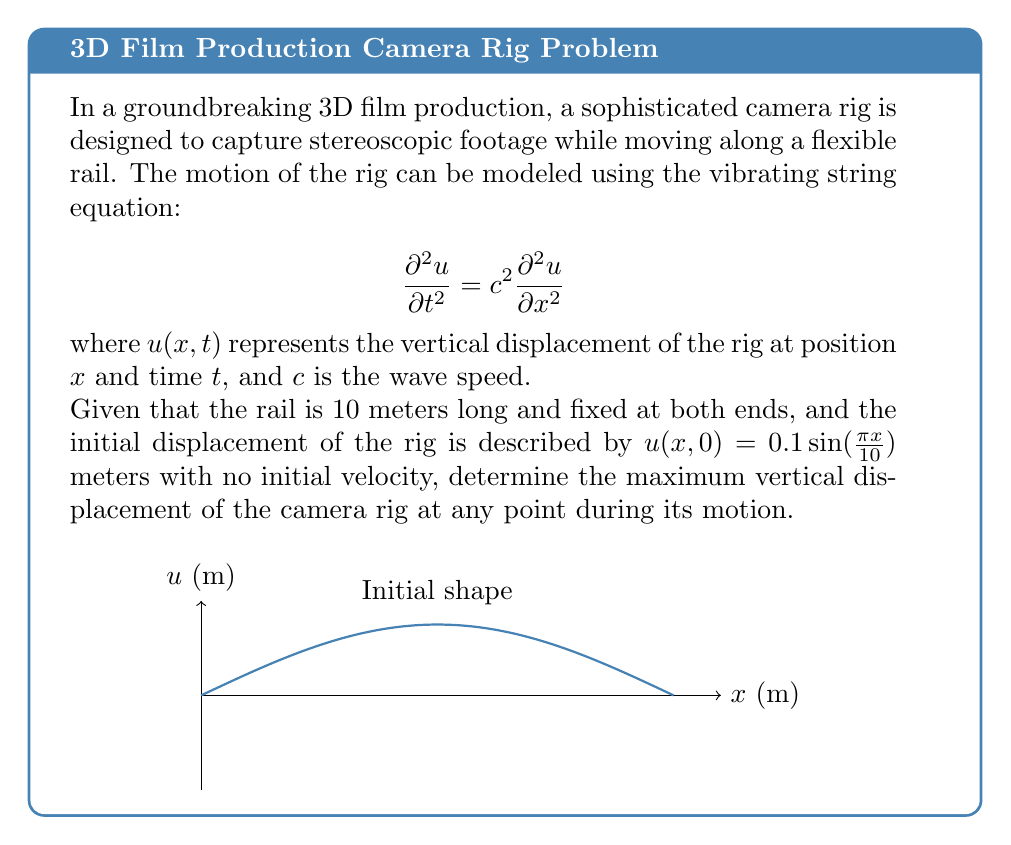What is the answer to this math problem? To solve this problem, we'll use the method of separation of variables for the wave equation:

1) The general solution for the wave equation with fixed endpoints is:

   $$u(x,t) = \sum_{n=1}^{\infty} (A_n \cos(\omega_n t) + B_n \sin(\omega_n t)) \sin(\frac{n\pi x}{L})$$

   where $\omega_n = \frac{n\pi c}{L}$, and $L$ is the length of the string (10 m in this case).

2) Given the initial conditions:
   $u(x,0) = 0.1 \sin(\frac{\pi x}{10})$
   $\frac{\partial u}{\partial t}(x,0) = 0$

3) Comparing the initial displacement with the general solution at $t=0$:
   $0.1 \sin(\frac{\pi x}{10}) = \sum_{n=1}^{\infty} A_n \sin(\frac{n\pi x}{10})$

4) We can see that only the first term ($n=1$) matches, so:
   $A_1 = 0.1$ and $A_n = 0$ for $n > 1$

5) The initial velocity condition gives us:
   $0 = \sum_{n=1}^{\infty} B_n \omega_n \sin(\frac{n\pi x}{10})$

   This implies $B_n = 0$ for all $n$.

6) Therefore, our solution simplifies to:
   $$u(x,t) = 0.1 \cos(\frac{\pi c t}{10}) \sin(\frac{\pi x}{10})$$

7) The maximum displacement occurs when $\cos(\frac{\pi c t}{10}) = \pm 1$ and $\sin(\frac{\pi x}{10}) = \pm 1$, which gives:

   $$|u_{max}| = 0.1 \text{ meters}$$

Thus, the maximum vertical displacement of the camera rig at any point during its motion is 0.1 meters.
Answer: 0.1 meters 